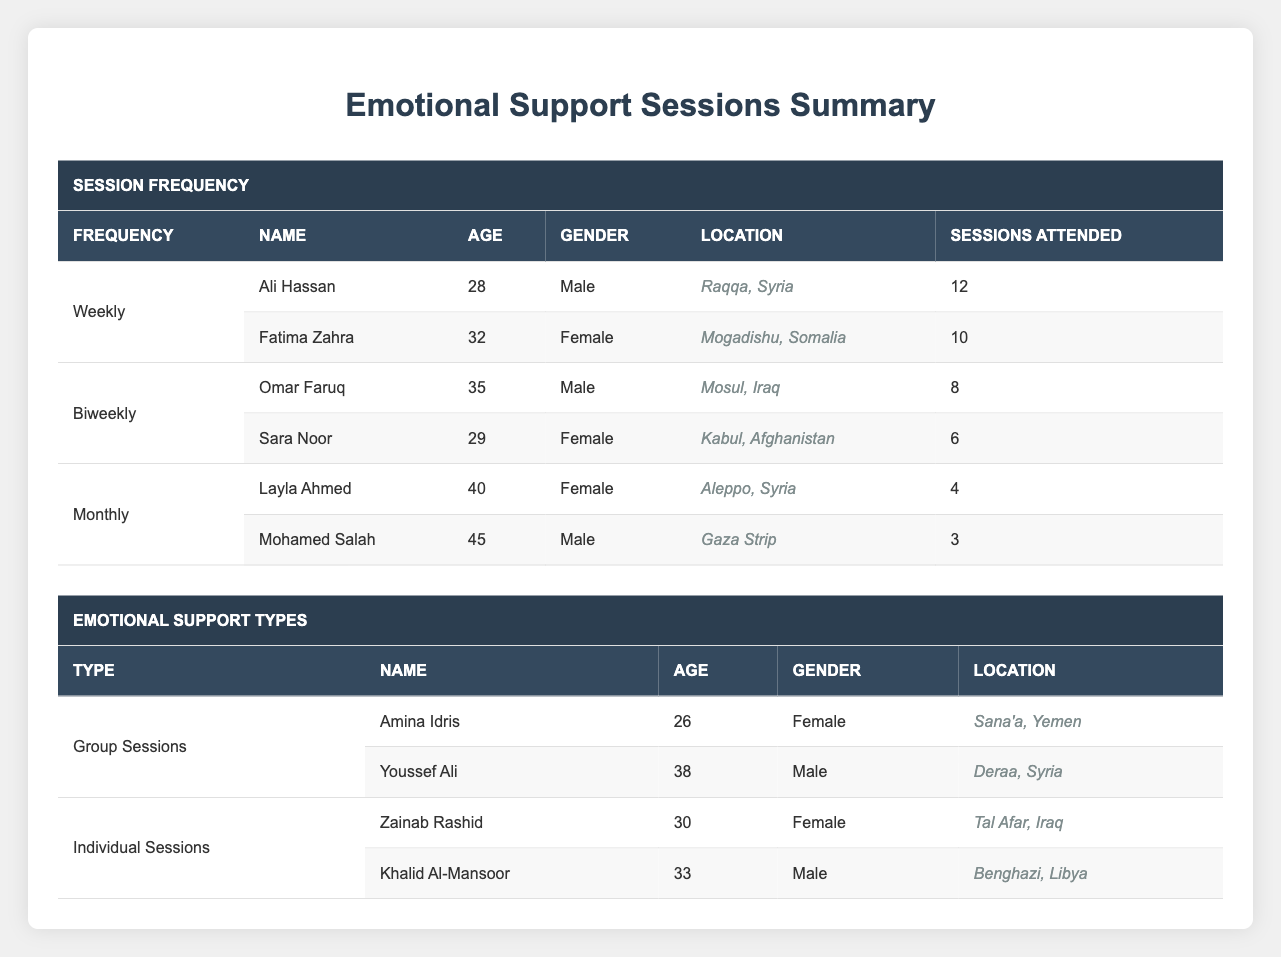What is the age of Fatima Zahra? From the weekly session participants, Fatima Zahra is listed in the table with her age shown in the corresponding column.
Answer: 32 How many participants attended sessions biweekly? Two participants are listed under the biweekly session frequency: Omar Faruq and Sara Noor.
Answer: 2 Who attended the most sessions among the monthly participants? Among the monthly participants, Layla Ahmed attended 4 sessions, while Mohamed Salah attended 3 sessions. Hence, Layla Ahmed attended the most sessions.
Answer: Layla Ahmed What is the total number of sessions attended by all participants in weekly sessions? Add the sessions attended by the two participants in the weekly section: 12 (Ali Hassan) + 10 (Fatima Zahra) = 22.
Answer: 22 Is Khalid Al-Mansoor from Libya a participant in group sessions? Khalid Al-Mansoor is listed under individual sessions only, meaning he is not part of the group sessions.
Answer: No Which gender has the highest total participation across all sessions? Count the number of male and female participants: Male: 5 (Ali, Omar, Mohamed, Youssef, Khalid) and Female: 5 (Fatima, Sara, Layla, Amina, Zainab). Males and females are equal in participation.
Answer: Equal How many total sessions were attended by male participants in individual sessions? Add the sessions attended by male participants under individual sessions: Khalid Al-Mansoor attended 10 sessions, and there are no other male participants in this category.
Answer: 10 What is the difference in the number of sessions attended between Ali Hassan and Sara Noor? Ali Hassan attended 12 sessions while Sara Noor attended 6 sessions. Thus, the difference is 12 - 6 = 6 sessions.
Answer: 6 Which participant from monthly sessions is older, and what is their age difference? Compare the ages of monthly participants: Layla Ahmed (40) and Mohamed Salah (45). Mohamed Salah is older, and the difference is 45 - 40 = 5 years.
Answer: 5 years difference, Mohamed Salah is older 